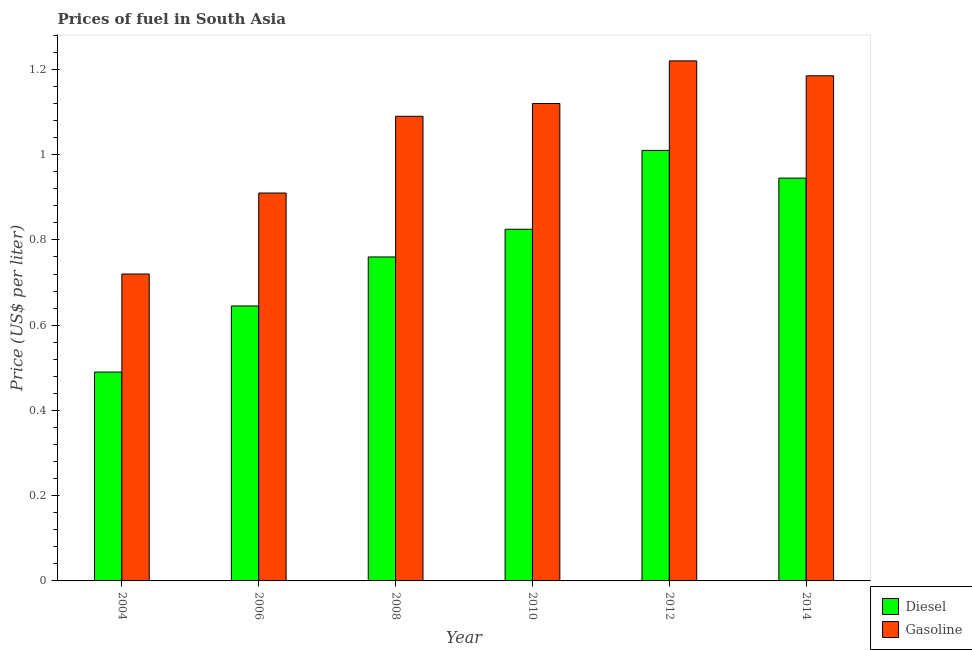How many groups of bars are there?
Provide a succinct answer. 6. Are the number of bars per tick equal to the number of legend labels?
Your answer should be very brief. Yes. Are the number of bars on each tick of the X-axis equal?
Offer a terse response. Yes. How many bars are there on the 5th tick from the right?
Ensure brevity in your answer.  2. What is the label of the 2nd group of bars from the left?
Offer a terse response. 2006. What is the diesel price in 2014?
Provide a succinct answer. 0.94. Across all years, what is the minimum gasoline price?
Keep it short and to the point. 0.72. In which year was the diesel price maximum?
Ensure brevity in your answer.  2012. What is the total diesel price in the graph?
Your answer should be compact. 4.67. What is the difference between the gasoline price in 2008 and that in 2012?
Ensure brevity in your answer.  -0.13. What is the difference between the gasoline price in 2006 and the diesel price in 2014?
Your answer should be very brief. -0.28. What is the average gasoline price per year?
Your response must be concise. 1.04. What is the ratio of the gasoline price in 2004 to that in 2012?
Provide a succinct answer. 0.59. What is the difference between the highest and the second highest gasoline price?
Ensure brevity in your answer.  0.03. What is the difference between the highest and the lowest gasoline price?
Offer a terse response. 0.5. Is the sum of the gasoline price in 2008 and 2014 greater than the maximum diesel price across all years?
Give a very brief answer. Yes. What does the 2nd bar from the left in 2008 represents?
Make the answer very short. Gasoline. What does the 1st bar from the right in 2008 represents?
Make the answer very short. Gasoline. How many bars are there?
Your answer should be very brief. 12. Are all the bars in the graph horizontal?
Provide a short and direct response. No. Are the values on the major ticks of Y-axis written in scientific E-notation?
Your answer should be compact. No. Does the graph contain grids?
Ensure brevity in your answer.  No. How are the legend labels stacked?
Provide a short and direct response. Vertical. What is the title of the graph?
Offer a very short reply. Prices of fuel in South Asia. Does "Birth rate" appear as one of the legend labels in the graph?
Your response must be concise. No. What is the label or title of the Y-axis?
Provide a short and direct response. Price (US$ per liter). What is the Price (US$ per liter) of Diesel in 2004?
Your answer should be very brief. 0.49. What is the Price (US$ per liter) of Gasoline in 2004?
Offer a terse response. 0.72. What is the Price (US$ per liter) of Diesel in 2006?
Your answer should be very brief. 0.65. What is the Price (US$ per liter) in Gasoline in 2006?
Your response must be concise. 0.91. What is the Price (US$ per liter) in Diesel in 2008?
Your answer should be very brief. 0.76. What is the Price (US$ per liter) of Gasoline in 2008?
Give a very brief answer. 1.09. What is the Price (US$ per liter) of Diesel in 2010?
Provide a succinct answer. 0.82. What is the Price (US$ per liter) of Gasoline in 2010?
Your response must be concise. 1.12. What is the Price (US$ per liter) in Diesel in 2012?
Your answer should be compact. 1.01. What is the Price (US$ per liter) of Gasoline in 2012?
Your answer should be very brief. 1.22. What is the Price (US$ per liter) of Diesel in 2014?
Offer a very short reply. 0.94. What is the Price (US$ per liter) of Gasoline in 2014?
Offer a very short reply. 1.19. Across all years, what is the maximum Price (US$ per liter) of Gasoline?
Make the answer very short. 1.22. Across all years, what is the minimum Price (US$ per liter) of Diesel?
Provide a short and direct response. 0.49. Across all years, what is the minimum Price (US$ per liter) in Gasoline?
Offer a terse response. 0.72. What is the total Price (US$ per liter) of Diesel in the graph?
Ensure brevity in your answer.  4.67. What is the total Price (US$ per liter) in Gasoline in the graph?
Keep it short and to the point. 6.25. What is the difference between the Price (US$ per liter) of Diesel in 2004 and that in 2006?
Your response must be concise. -0.15. What is the difference between the Price (US$ per liter) of Gasoline in 2004 and that in 2006?
Give a very brief answer. -0.19. What is the difference between the Price (US$ per liter) in Diesel in 2004 and that in 2008?
Make the answer very short. -0.27. What is the difference between the Price (US$ per liter) of Gasoline in 2004 and that in 2008?
Offer a terse response. -0.37. What is the difference between the Price (US$ per liter) in Diesel in 2004 and that in 2010?
Make the answer very short. -0.34. What is the difference between the Price (US$ per liter) of Gasoline in 2004 and that in 2010?
Provide a succinct answer. -0.4. What is the difference between the Price (US$ per liter) in Diesel in 2004 and that in 2012?
Keep it short and to the point. -0.52. What is the difference between the Price (US$ per liter) of Gasoline in 2004 and that in 2012?
Give a very brief answer. -0.5. What is the difference between the Price (US$ per liter) in Diesel in 2004 and that in 2014?
Offer a terse response. -0.46. What is the difference between the Price (US$ per liter) of Gasoline in 2004 and that in 2014?
Offer a terse response. -0.47. What is the difference between the Price (US$ per liter) in Diesel in 2006 and that in 2008?
Provide a succinct answer. -0.12. What is the difference between the Price (US$ per liter) of Gasoline in 2006 and that in 2008?
Provide a succinct answer. -0.18. What is the difference between the Price (US$ per liter) in Diesel in 2006 and that in 2010?
Offer a very short reply. -0.18. What is the difference between the Price (US$ per liter) of Gasoline in 2006 and that in 2010?
Your response must be concise. -0.21. What is the difference between the Price (US$ per liter) of Diesel in 2006 and that in 2012?
Your answer should be compact. -0.36. What is the difference between the Price (US$ per liter) of Gasoline in 2006 and that in 2012?
Give a very brief answer. -0.31. What is the difference between the Price (US$ per liter) of Gasoline in 2006 and that in 2014?
Give a very brief answer. -0.28. What is the difference between the Price (US$ per liter) in Diesel in 2008 and that in 2010?
Ensure brevity in your answer.  -0.07. What is the difference between the Price (US$ per liter) of Gasoline in 2008 and that in 2010?
Your answer should be compact. -0.03. What is the difference between the Price (US$ per liter) of Gasoline in 2008 and that in 2012?
Offer a very short reply. -0.13. What is the difference between the Price (US$ per liter) in Diesel in 2008 and that in 2014?
Make the answer very short. -0.18. What is the difference between the Price (US$ per liter) of Gasoline in 2008 and that in 2014?
Provide a short and direct response. -0.1. What is the difference between the Price (US$ per liter) of Diesel in 2010 and that in 2012?
Your answer should be very brief. -0.18. What is the difference between the Price (US$ per liter) in Diesel in 2010 and that in 2014?
Provide a short and direct response. -0.12. What is the difference between the Price (US$ per liter) in Gasoline in 2010 and that in 2014?
Your answer should be compact. -0.07. What is the difference between the Price (US$ per liter) in Diesel in 2012 and that in 2014?
Ensure brevity in your answer.  0.07. What is the difference between the Price (US$ per liter) in Gasoline in 2012 and that in 2014?
Offer a terse response. 0.04. What is the difference between the Price (US$ per liter) of Diesel in 2004 and the Price (US$ per liter) of Gasoline in 2006?
Offer a very short reply. -0.42. What is the difference between the Price (US$ per liter) in Diesel in 2004 and the Price (US$ per liter) in Gasoline in 2008?
Ensure brevity in your answer.  -0.6. What is the difference between the Price (US$ per liter) in Diesel in 2004 and the Price (US$ per liter) in Gasoline in 2010?
Your answer should be very brief. -0.63. What is the difference between the Price (US$ per liter) in Diesel in 2004 and the Price (US$ per liter) in Gasoline in 2012?
Offer a terse response. -0.73. What is the difference between the Price (US$ per liter) in Diesel in 2004 and the Price (US$ per liter) in Gasoline in 2014?
Give a very brief answer. -0.69. What is the difference between the Price (US$ per liter) of Diesel in 2006 and the Price (US$ per liter) of Gasoline in 2008?
Offer a terse response. -0.45. What is the difference between the Price (US$ per liter) in Diesel in 2006 and the Price (US$ per liter) in Gasoline in 2010?
Offer a very short reply. -0.47. What is the difference between the Price (US$ per liter) of Diesel in 2006 and the Price (US$ per liter) of Gasoline in 2012?
Your response must be concise. -0.57. What is the difference between the Price (US$ per liter) of Diesel in 2006 and the Price (US$ per liter) of Gasoline in 2014?
Provide a short and direct response. -0.54. What is the difference between the Price (US$ per liter) of Diesel in 2008 and the Price (US$ per liter) of Gasoline in 2010?
Provide a short and direct response. -0.36. What is the difference between the Price (US$ per liter) of Diesel in 2008 and the Price (US$ per liter) of Gasoline in 2012?
Offer a very short reply. -0.46. What is the difference between the Price (US$ per liter) of Diesel in 2008 and the Price (US$ per liter) of Gasoline in 2014?
Make the answer very short. -0.42. What is the difference between the Price (US$ per liter) of Diesel in 2010 and the Price (US$ per liter) of Gasoline in 2012?
Ensure brevity in your answer.  -0.4. What is the difference between the Price (US$ per liter) in Diesel in 2010 and the Price (US$ per liter) in Gasoline in 2014?
Your answer should be very brief. -0.36. What is the difference between the Price (US$ per liter) of Diesel in 2012 and the Price (US$ per liter) of Gasoline in 2014?
Provide a succinct answer. -0.17. What is the average Price (US$ per liter) in Diesel per year?
Provide a short and direct response. 0.78. What is the average Price (US$ per liter) in Gasoline per year?
Give a very brief answer. 1.04. In the year 2004, what is the difference between the Price (US$ per liter) in Diesel and Price (US$ per liter) in Gasoline?
Offer a very short reply. -0.23. In the year 2006, what is the difference between the Price (US$ per liter) of Diesel and Price (US$ per liter) of Gasoline?
Ensure brevity in your answer.  -0.27. In the year 2008, what is the difference between the Price (US$ per liter) of Diesel and Price (US$ per liter) of Gasoline?
Give a very brief answer. -0.33. In the year 2010, what is the difference between the Price (US$ per liter) in Diesel and Price (US$ per liter) in Gasoline?
Your answer should be very brief. -0.29. In the year 2012, what is the difference between the Price (US$ per liter) of Diesel and Price (US$ per liter) of Gasoline?
Your response must be concise. -0.21. In the year 2014, what is the difference between the Price (US$ per liter) in Diesel and Price (US$ per liter) in Gasoline?
Provide a succinct answer. -0.24. What is the ratio of the Price (US$ per liter) in Diesel in 2004 to that in 2006?
Offer a terse response. 0.76. What is the ratio of the Price (US$ per liter) in Gasoline in 2004 to that in 2006?
Provide a succinct answer. 0.79. What is the ratio of the Price (US$ per liter) of Diesel in 2004 to that in 2008?
Your response must be concise. 0.64. What is the ratio of the Price (US$ per liter) in Gasoline in 2004 to that in 2008?
Provide a short and direct response. 0.66. What is the ratio of the Price (US$ per liter) in Diesel in 2004 to that in 2010?
Keep it short and to the point. 0.59. What is the ratio of the Price (US$ per liter) in Gasoline in 2004 to that in 2010?
Offer a very short reply. 0.64. What is the ratio of the Price (US$ per liter) of Diesel in 2004 to that in 2012?
Ensure brevity in your answer.  0.49. What is the ratio of the Price (US$ per liter) of Gasoline in 2004 to that in 2012?
Provide a succinct answer. 0.59. What is the ratio of the Price (US$ per liter) in Diesel in 2004 to that in 2014?
Your answer should be compact. 0.52. What is the ratio of the Price (US$ per liter) of Gasoline in 2004 to that in 2014?
Offer a terse response. 0.61. What is the ratio of the Price (US$ per liter) of Diesel in 2006 to that in 2008?
Your response must be concise. 0.85. What is the ratio of the Price (US$ per liter) of Gasoline in 2006 to that in 2008?
Your answer should be compact. 0.83. What is the ratio of the Price (US$ per liter) in Diesel in 2006 to that in 2010?
Your answer should be compact. 0.78. What is the ratio of the Price (US$ per liter) in Gasoline in 2006 to that in 2010?
Your response must be concise. 0.81. What is the ratio of the Price (US$ per liter) in Diesel in 2006 to that in 2012?
Ensure brevity in your answer.  0.64. What is the ratio of the Price (US$ per liter) in Gasoline in 2006 to that in 2012?
Your answer should be compact. 0.75. What is the ratio of the Price (US$ per liter) of Diesel in 2006 to that in 2014?
Your response must be concise. 0.68. What is the ratio of the Price (US$ per liter) of Gasoline in 2006 to that in 2014?
Provide a succinct answer. 0.77. What is the ratio of the Price (US$ per liter) in Diesel in 2008 to that in 2010?
Your answer should be very brief. 0.92. What is the ratio of the Price (US$ per liter) of Gasoline in 2008 to that in 2010?
Make the answer very short. 0.97. What is the ratio of the Price (US$ per liter) in Diesel in 2008 to that in 2012?
Your answer should be compact. 0.75. What is the ratio of the Price (US$ per liter) of Gasoline in 2008 to that in 2012?
Offer a very short reply. 0.89. What is the ratio of the Price (US$ per liter) in Diesel in 2008 to that in 2014?
Your response must be concise. 0.8. What is the ratio of the Price (US$ per liter) of Gasoline in 2008 to that in 2014?
Keep it short and to the point. 0.92. What is the ratio of the Price (US$ per liter) of Diesel in 2010 to that in 2012?
Your answer should be compact. 0.82. What is the ratio of the Price (US$ per liter) in Gasoline in 2010 to that in 2012?
Offer a terse response. 0.92. What is the ratio of the Price (US$ per liter) in Diesel in 2010 to that in 2014?
Offer a terse response. 0.87. What is the ratio of the Price (US$ per liter) in Gasoline in 2010 to that in 2014?
Ensure brevity in your answer.  0.95. What is the ratio of the Price (US$ per liter) in Diesel in 2012 to that in 2014?
Provide a succinct answer. 1.07. What is the ratio of the Price (US$ per liter) in Gasoline in 2012 to that in 2014?
Ensure brevity in your answer.  1.03. What is the difference between the highest and the second highest Price (US$ per liter) in Diesel?
Give a very brief answer. 0.07. What is the difference between the highest and the second highest Price (US$ per liter) of Gasoline?
Ensure brevity in your answer.  0.04. What is the difference between the highest and the lowest Price (US$ per liter) in Diesel?
Your answer should be very brief. 0.52. 